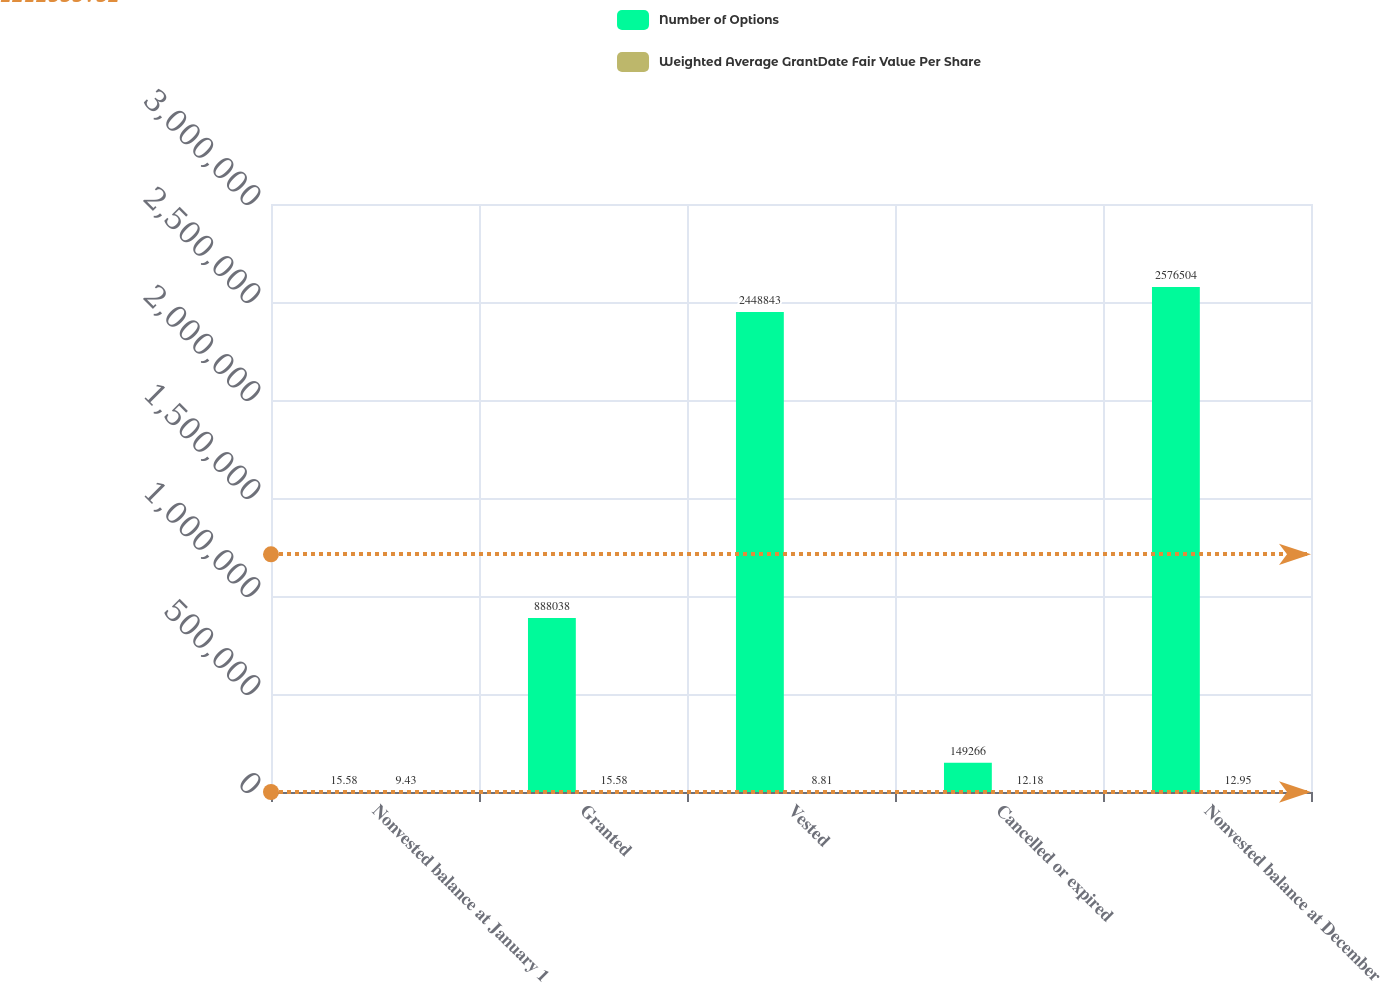Convert chart. <chart><loc_0><loc_0><loc_500><loc_500><stacked_bar_chart><ecel><fcel>Nonvested balance at January 1<fcel>Granted<fcel>Vested<fcel>Cancelled or expired<fcel>Nonvested balance at December<nl><fcel>Number of Options<fcel>15.58<fcel>888038<fcel>2.44884e+06<fcel>149266<fcel>2.5765e+06<nl><fcel>Weighted Average GrantDate Fair Value Per Share<fcel>9.43<fcel>15.58<fcel>8.81<fcel>12.18<fcel>12.95<nl></chart> 